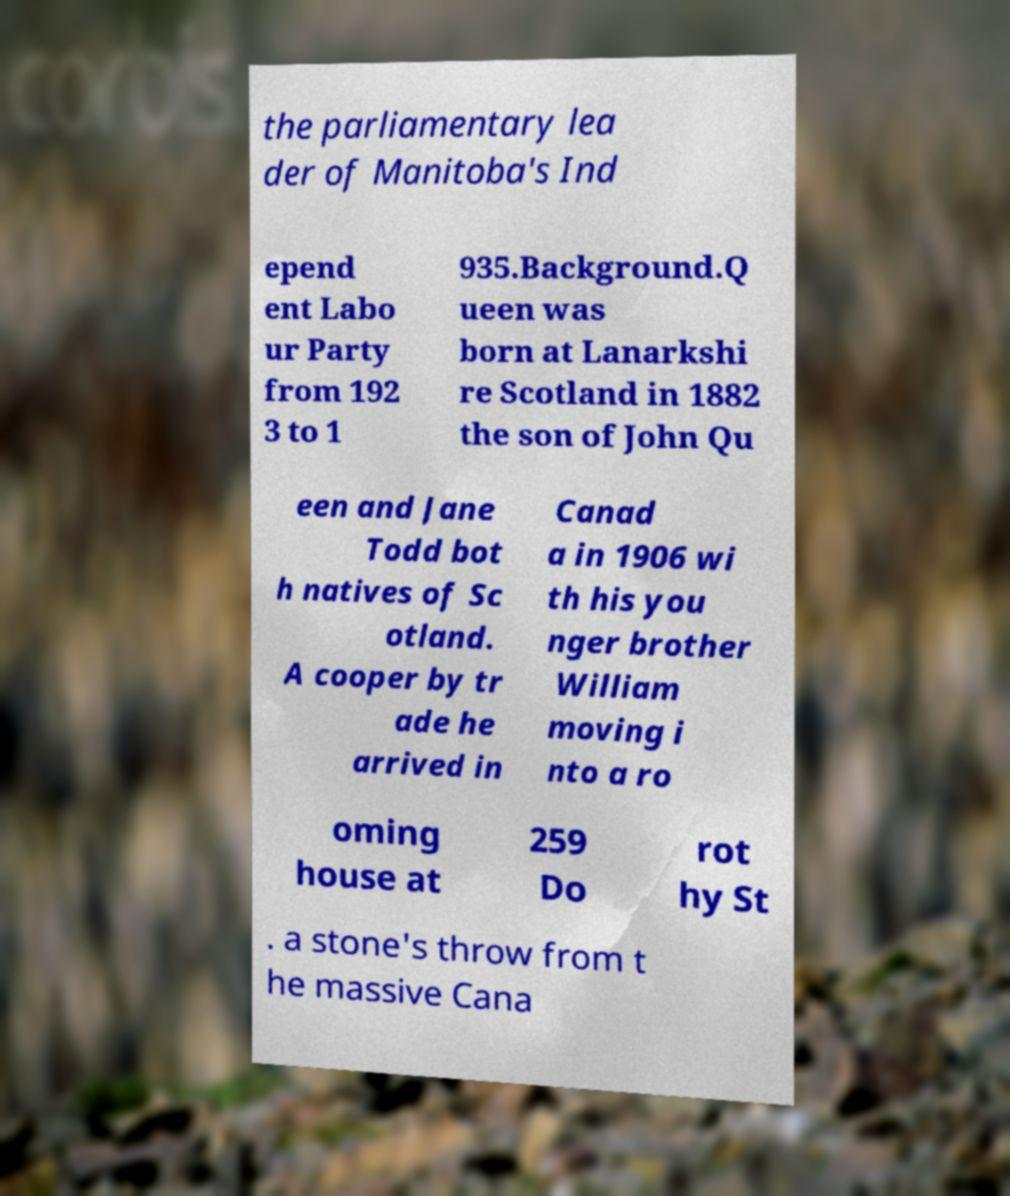Could you extract and type out the text from this image? the parliamentary lea der of Manitoba's Ind epend ent Labo ur Party from 192 3 to 1 935.Background.Q ueen was born at Lanarkshi re Scotland in 1882 the son of John Qu een and Jane Todd bot h natives of Sc otland. A cooper by tr ade he arrived in Canad a in 1906 wi th his you nger brother William moving i nto a ro oming house at 259 Do rot hy St . a stone's throw from t he massive Cana 